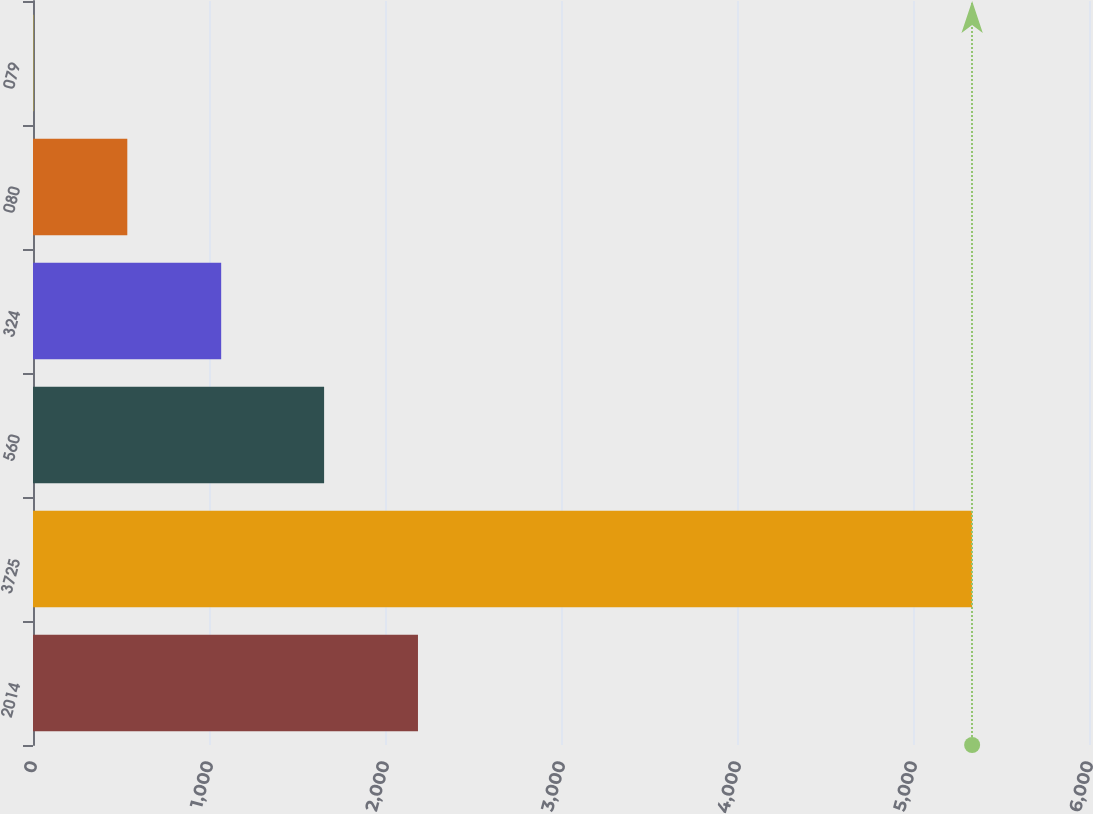<chart> <loc_0><loc_0><loc_500><loc_500><bar_chart><fcel>2014<fcel>3725<fcel>560<fcel>324<fcel>080<fcel>079<nl><fcel>2187.35<fcel>5336<fcel>1654<fcel>1069.17<fcel>535.82<fcel>2.47<nl></chart> 